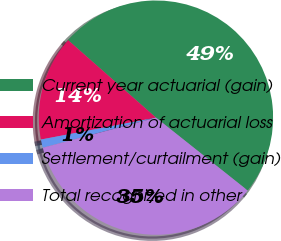Convert chart. <chart><loc_0><loc_0><loc_500><loc_500><pie_chart><fcel>Current year actuarial (gain)<fcel>Amortization of actuarial loss<fcel>Settlement/curtailment (gain)<fcel>Total recognized in other<nl><fcel>49.19%<fcel>14.5%<fcel>1.14%<fcel>35.18%<nl></chart> 